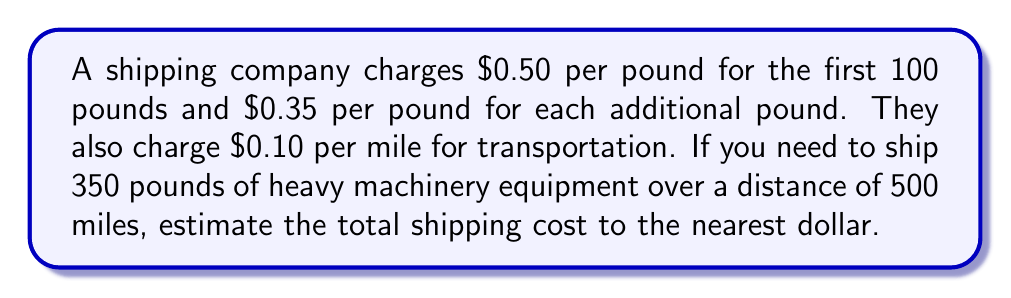Help me with this question. Let's break this down step-by-step:

1. Calculate the cost for the first 100 pounds:
   $100 \times \$0.50 = \$50$

2. Calculate the cost for the remaining 250 pounds:
   $250 \times \$0.35 = \$87.50$

3. Sum up the total weight-based cost:
   $\$50 + \$87.50 = \$137.50$

4. Calculate the distance-based cost:
   $500 \text{ miles} \times \$0.10/\text{mile} = \$50$

5. Sum up the total cost:
   $\$137.50 + \$50 = \$187.50$

6. Round to the nearest dollar:
   $\$187.50 \approx \$188$

Therefore, the estimated shipping cost is $188.
Answer: $188 